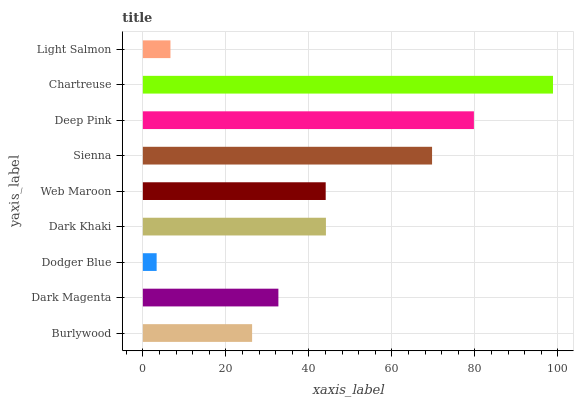Is Dodger Blue the minimum?
Answer yes or no. Yes. Is Chartreuse the maximum?
Answer yes or no. Yes. Is Dark Magenta the minimum?
Answer yes or no. No. Is Dark Magenta the maximum?
Answer yes or no. No. Is Dark Magenta greater than Burlywood?
Answer yes or no. Yes. Is Burlywood less than Dark Magenta?
Answer yes or no. Yes. Is Burlywood greater than Dark Magenta?
Answer yes or no. No. Is Dark Magenta less than Burlywood?
Answer yes or no. No. Is Web Maroon the high median?
Answer yes or no. Yes. Is Web Maroon the low median?
Answer yes or no. Yes. Is Deep Pink the high median?
Answer yes or no. No. Is Dark Khaki the low median?
Answer yes or no. No. 